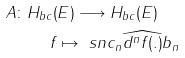Convert formula to latex. <formula><loc_0><loc_0><loc_500><loc_500>A \colon H _ { b c } ( & E ) \longrightarrow H _ { b c } ( E ) \\ f & \mapsto \ s n c _ { n } \widehat { d ^ { n } f ( . ) } b _ { n }</formula> 